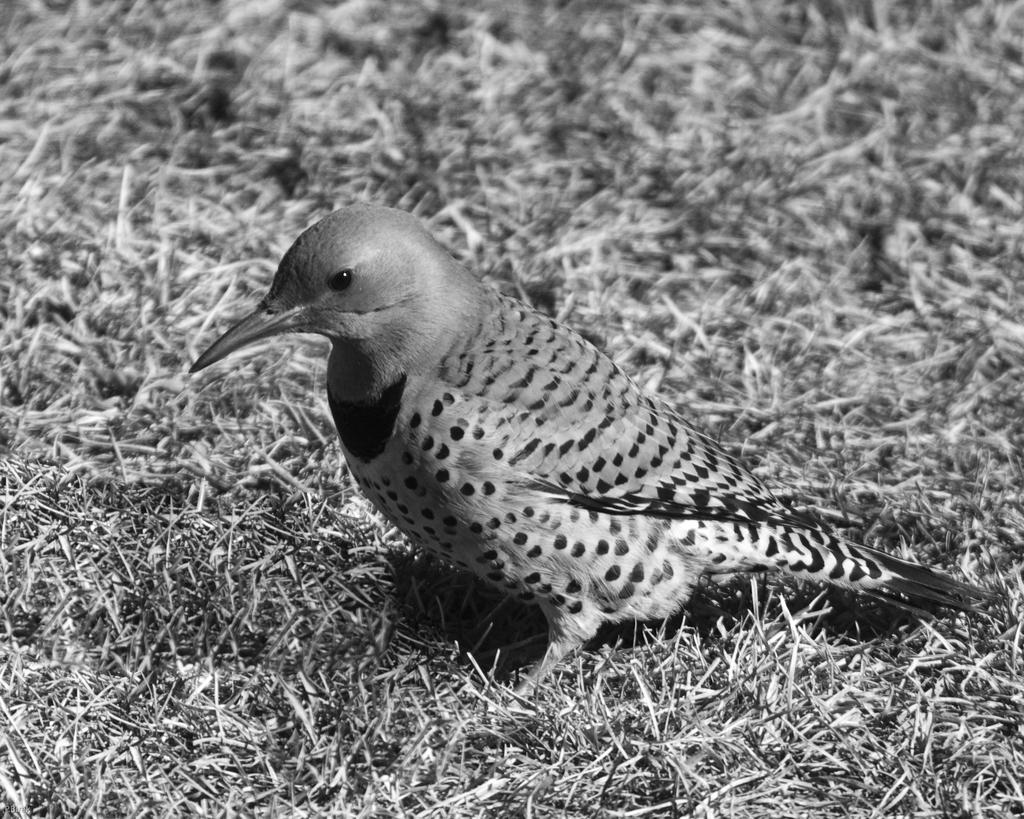What is the main subject in the center of the image? There is a bird in the center of the image. What type of natural environment is visible at the bottom of the image? There is grass at the bottom of the image. What type of food is the bird eating in the image? There is no food visible in the image, and therefore it cannot be determined what the bird might be eating. 